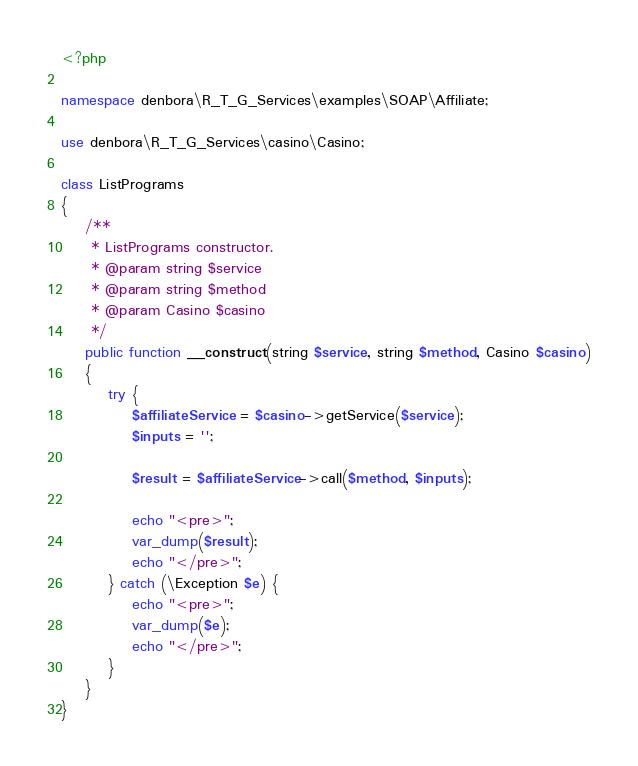Convert code to text. <code><loc_0><loc_0><loc_500><loc_500><_PHP_><?php

namespace denbora\R_T_G_Services\examples\SOAP\Affiliate;

use denbora\R_T_G_Services\casino\Casino;

class ListPrograms
{
    /**
     * ListPrograms constructor.
     * @param string $service
     * @param string $method
     * @param Casino $casino
     */
    public function __construct(string $service, string $method, Casino $casino)
    {
        try {
            $affiliateService = $casino->getService($service);
            $inputs = '';

            $result = $affiliateService->call($method, $inputs);

            echo "<pre>";
            var_dump($result);
            echo "</pre>";
        } catch (\Exception $e) {
            echo "<pre>";
            var_dump($e);
            echo "</pre>";
        }
    }
}
</code> 